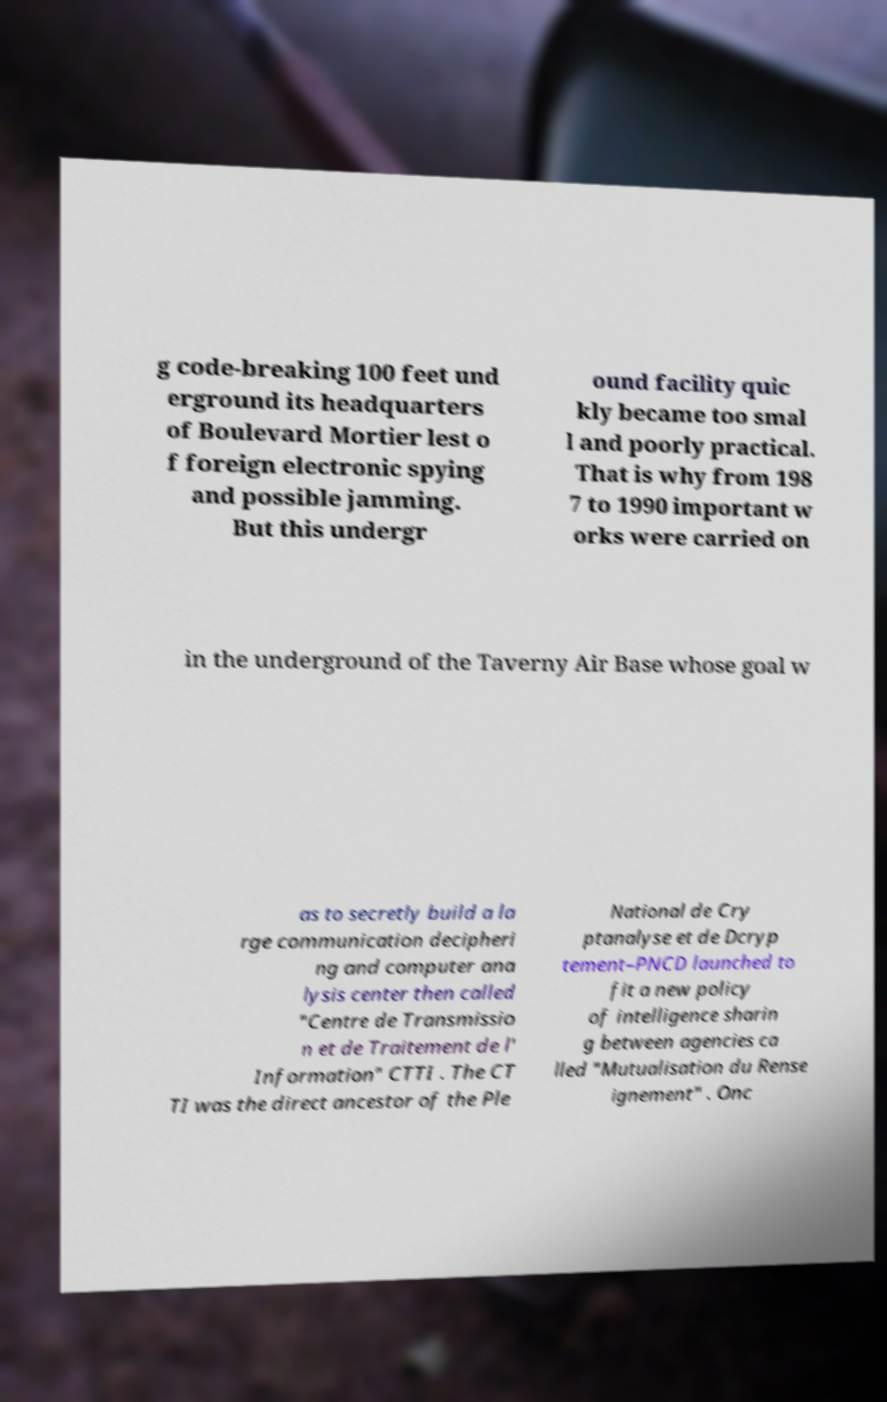I need the written content from this picture converted into text. Can you do that? g code-breaking 100 feet und erground its headquarters of Boulevard Mortier lest o f foreign electronic spying and possible jamming. But this undergr ound facility quic kly became too smal l and poorly practical. That is why from 198 7 to 1990 important w orks were carried on in the underground of the Taverny Air Base whose goal w as to secretly build a la rge communication decipheri ng and computer ana lysis center then called "Centre de Transmissio n et de Traitement de l' Information" CTTI . The CT TI was the direct ancestor of the Ple National de Cry ptanalyse et de Dcryp tement–PNCD launched to fit a new policy of intelligence sharin g between agencies ca lled "Mutualisation du Rense ignement" . Onc 